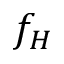<formula> <loc_0><loc_0><loc_500><loc_500>f _ { H }</formula> 